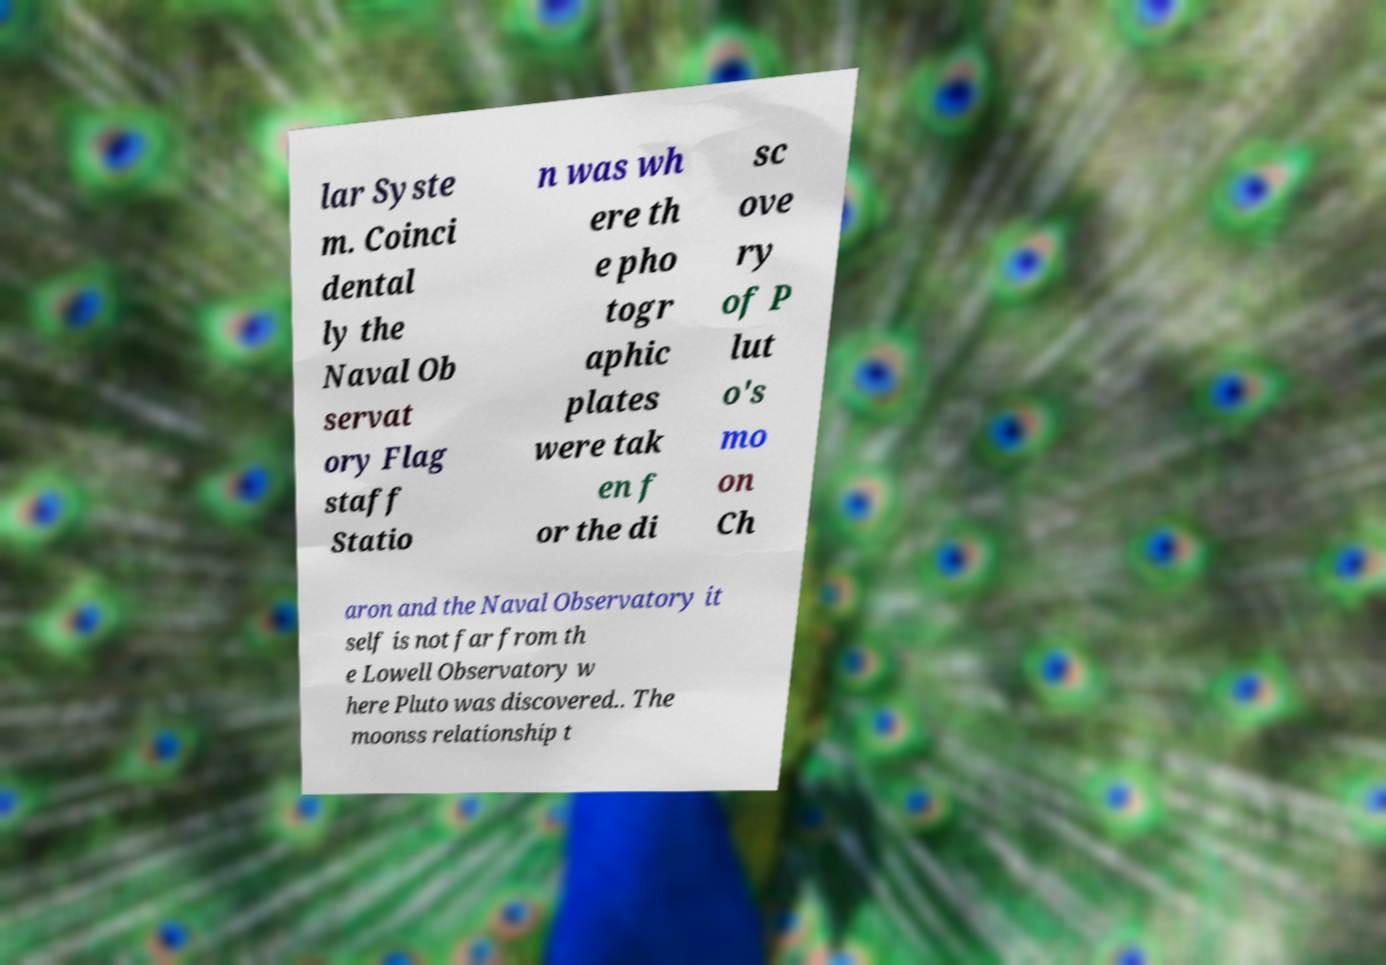I need the written content from this picture converted into text. Can you do that? lar Syste m. Coinci dental ly the Naval Ob servat ory Flag staff Statio n was wh ere th e pho togr aphic plates were tak en f or the di sc ove ry of P lut o's mo on Ch aron and the Naval Observatory it self is not far from th e Lowell Observatory w here Pluto was discovered.. The moonss relationship t 